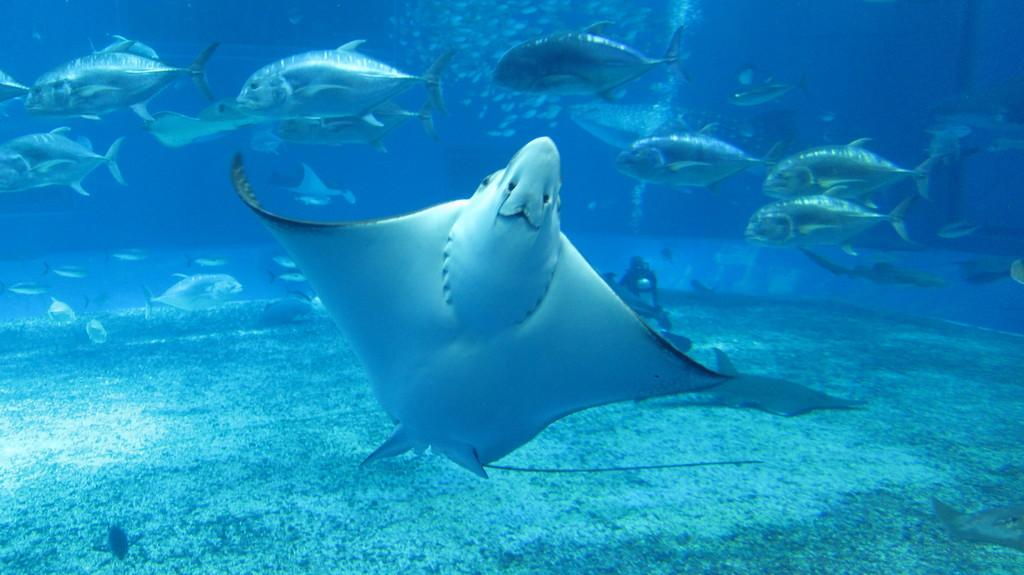What type of environment is shown in the image? The image depicts an underwater environment. What types of creatures can be seen in the image? There are fishes in the image. Is there a person present in the image? Yes, there is a person in the image. What else can be observed in the image besides the fishes and person? Water bubbles are visible in the image. Where is the sheep located in the image? There is no sheep present in the image; it is an underwater environment with fishes and a person. 